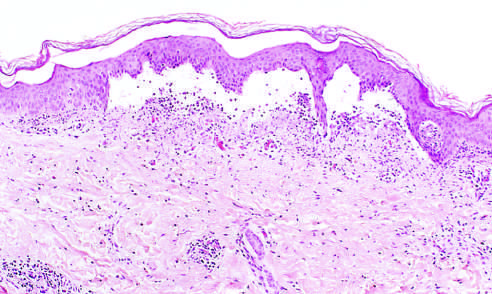s the irreversible injury separated from the dermis by a focal collection of serous effusion?
Answer the question using a single word or phrase. No 